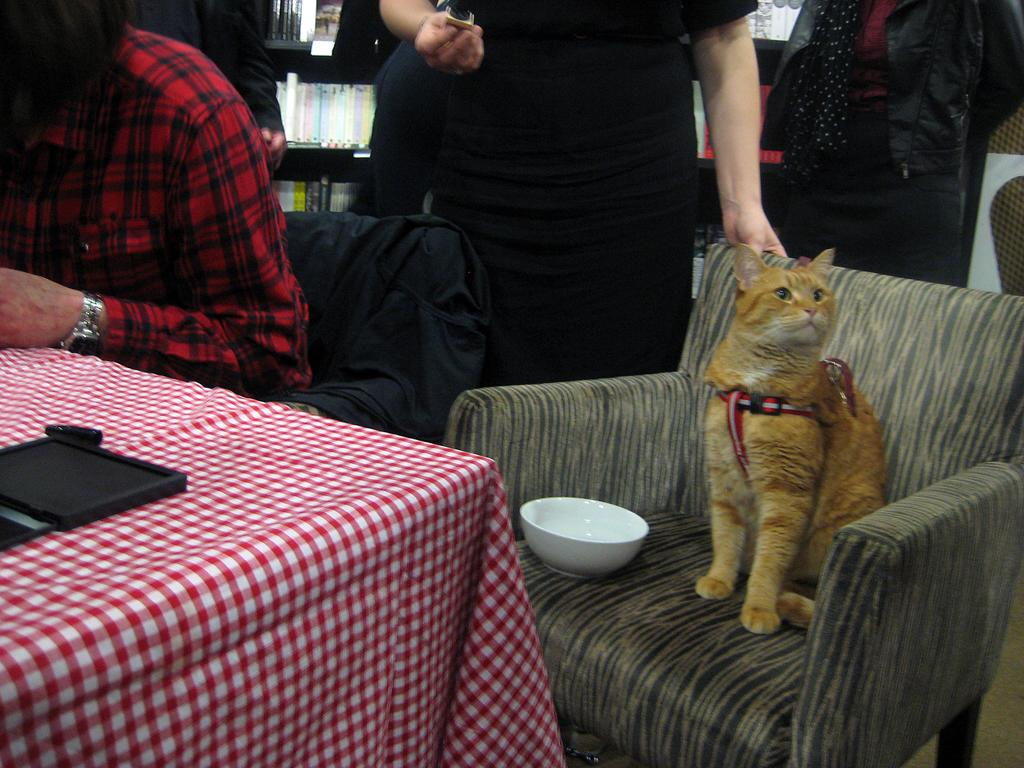What is the person in the image doing? The person is sitting on a chair in the image. What animal is also sitting on the chair? There is a cat sitting on the chair with the person. What object can be seen on the table in the image? There is a bowl on the table in the image. What is covering the table in the image? There is a table cloth on the table. What are the people standing on in the image? The people are standing on the floor. What can be seen arranged on the table or floor in the image? There are books arranged in rows in the image. What color is the orange on the table in the image? There is no orange present in the image. How many zippers can be seen on the cat in the image? There are no zippers on the cat in the image, as cats do not have zippers. 